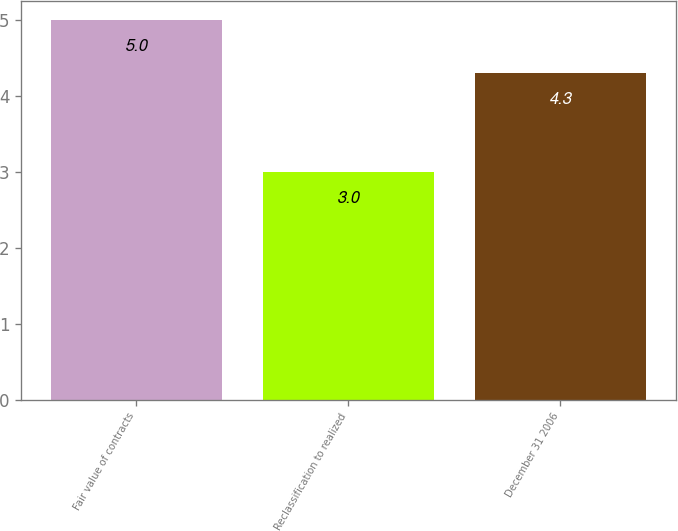Convert chart. <chart><loc_0><loc_0><loc_500><loc_500><bar_chart><fcel>Fair value of contracts<fcel>Reclassification to realized<fcel>December 31 2006<nl><fcel>5<fcel>3<fcel>4.3<nl></chart> 